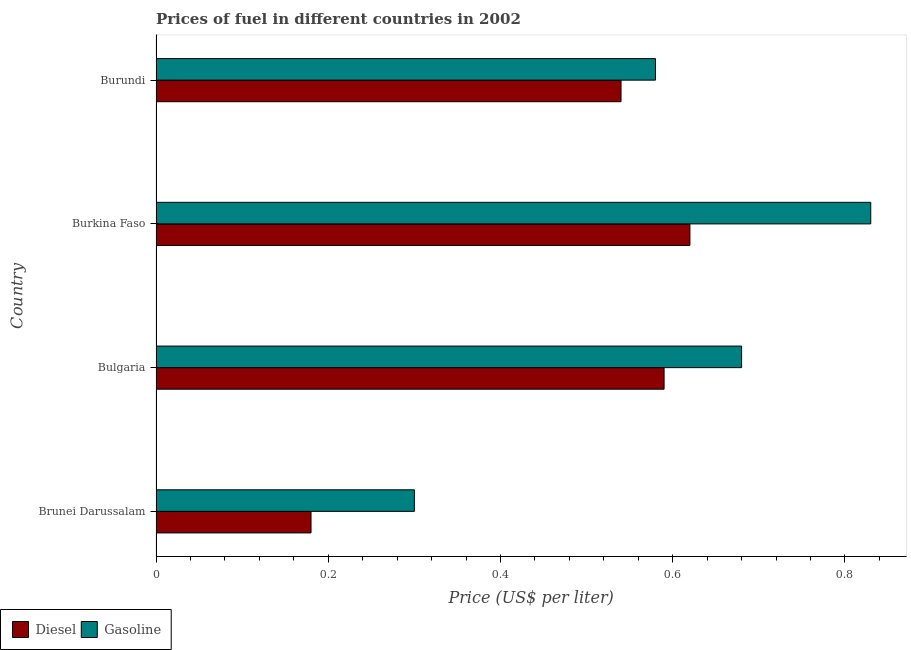Are the number of bars per tick equal to the number of legend labels?
Provide a short and direct response. Yes. What is the label of the 1st group of bars from the top?
Keep it short and to the point. Burundi. In how many cases, is the number of bars for a given country not equal to the number of legend labels?
Your answer should be compact. 0. What is the diesel price in Burundi?
Your response must be concise. 0.54. Across all countries, what is the maximum diesel price?
Give a very brief answer. 0.62. Across all countries, what is the minimum diesel price?
Provide a succinct answer. 0.18. In which country was the gasoline price maximum?
Provide a short and direct response. Burkina Faso. In which country was the gasoline price minimum?
Make the answer very short. Brunei Darussalam. What is the total gasoline price in the graph?
Provide a succinct answer. 2.39. What is the difference between the diesel price in Brunei Darussalam and that in Burundi?
Provide a succinct answer. -0.36. What is the difference between the gasoline price in Burundi and the diesel price in Brunei Darussalam?
Keep it short and to the point. 0.4. What is the average gasoline price per country?
Your answer should be compact. 0.6. What is the difference between the gasoline price and diesel price in Brunei Darussalam?
Make the answer very short. 0.12. In how many countries, is the gasoline price greater than 0.36 US$ per litre?
Provide a succinct answer. 3. What is the ratio of the gasoline price in Burkina Faso to that in Burundi?
Provide a succinct answer. 1.43. Is the difference between the gasoline price in Brunei Darussalam and Burkina Faso greater than the difference between the diesel price in Brunei Darussalam and Burkina Faso?
Provide a succinct answer. No. What is the difference between the highest and the lowest gasoline price?
Ensure brevity in your answer.  0.53. In how many countries, is the diesel price greater than the average diesel price taken over all countries?
Give a very brief answer. 3. Is the sum of the diesel price in Brunei Darussalam and Burundi greater than the maximum gasoline price across all countries?
Ensure brevity in your answer.  No. What does the 1st bar from the top in Bulgaria represents?
Provide a succinct answer. Gasoline. What does the 2nd bar from the bottom in Burundi represents?
Provide a short and direct response. Gasoline. How many countries are there in the graph?
Give a very brief answer. 4. Where does the legend appear in the graph?
Provide a succinct answer. Bottom left. How are the legend labels stacked?
Give a very brief answer. Horizontal. What is the title of the graph?
Provide a succinct answer. Prices of fuel in different countries in 2002. What is the label or title of the X-axis?
Your answer should be very brief. Price (US$ per liter). What is the Price (US$ per liter) in Diesel in Brunei Darussalam?
Ensure brevity in your answer.  0.18. What is the Price (US$ per liter) of Diesel in Bulgaria?
Provide a short and direct response. 0.59. What is the Price (US$ per liter) of Gasoline in Bulgaria?
Your answer should be compact. 0.68. What is the Price (US$ per liter) in Diesel in Burkina Faso?
Provide a succinct answer. 0.62. What is the Price (US$ per liter) in Gasoline in Burkina Faso?
Provide a short and direct response. 0.83. What is the Price (US$ per liter) in Diesel in Burundi?
Ensure brevity in your answer.  0.54. What is the Price (US$ per liter) in Gasoline in Burundi?
Your response must be concise. 0.58. Across all countries, what is the maximum Price (US$ per liter) of Diesel?
Keep it short and to the point. 0.62. Across all countries, what is the maximum Price (US$ per liter) in Gasoline?
Your answer should be compact. 0.83. Across all countries, what is the minimum Price (US$ per liter) in Diesel?
Your response must be concise. 0.18. Across all countries, what is the minimum Price (US$ per liter) of Gasoline?
Your response must be concise. 0.3. What is the total Price (US$ per liter) of Diesel in the graph?
Your answer should be compact. 1.93. What is the total Price (US$ per liter) in Gasoline in the graph?
Your response must be concise. 2.39. What is the difference between the Price (US$ per liter) in Diesel in Brunei Darussalam and that in Bulgaria?
Offer a terse response. -0.41. What is the difference between the Price (US$ per liter) of Gasoline in Brunei Darussalam and that in Bulgaria?
Keep it short and to the point. -0.38. What is the difference between the Price (US$ per liter) of Diesel in Brunei Darussalam and that in Burkina Faso?
Your answer should be very brief. -0.44. What is the difference between the Price (US$ per liter) in Gasoline in Brunei Darussalam and that in Burkina Faso?
Give a very brief answer. -0.53. What is the difference between the Price (US$ per liter) in Diesel in Brunei Darussalam and that in Burundi?
Your response must be concise. -0.36. What is the difference between the Price (US$ per liter) in Gasoline in Brunei Darussalam and that in Burundi?
Your response must be concise. -0.28. What is the difference between the Price (US$ per liter) of Diesel in Bulgaria and that in Burkina Faso?
Keep it short and to the point. -0.03. What is the difference between the Price (US$ per liter) of Diesel in Bulgaria and that in Burundi?
Your answer should be compact. 0.05. What is the difference between the Price (US$ per liter) in Gasoline in Burkina Faso and that in Burundi?
Offer a very short reply. 0.25. What is the difference between the Price (US$ per liter) of Diesel in Brunei Darussalam and the Price (US$ per liter) of Gasoline in Bulgaria?
Provide a succinct answer. -0.5. What is the difference between the Price (US$ per liter) in Diesel in Brunei Darussalam and the Price (US$ per liter) in Gasoline in Burkina Faso?
Ensure brevity in your answer.  -0.65. What is the difference between the Price (US$ per liter) in Diesel in Brunei Darussalam and the Price (US$ per liter) in Gasoline in Burundi?
Offer a terse response. -0.4. What is the difference between the Price (US$ per liter) in Diesel in Bulgaria and the Price (US$ per liter) in Gasoline in Burkina Faso?
Offer a very short reply. -0.24. What is the difference between the Price (US$ per liter) in Diesel in Bulgaria and the Price (US$ per liter) in Gasoline in Burundi?
Ensure brevity in your answer.  0.01. What is the average Price (US$ per liter) in Diesel per country?
Your response must be concise. 0.48. What is the average Price (US$ per liter) in Gasoline per country?
Your response must be concise. 0.6. What is the difference between the Price (US$ per liter) in Diesel and Price (US$ per liter) in Gasoline in Brunei Darussalam?
Offer a very short reply. -0.12. What is the difference between the Price (US$ per liter) of Diesel and Price (US$ per liter) of Gasoline in Bulgaria?
Offer a very short reply. -0.09. What is the difference between the Price (US$ per liter) in Diesel and Price (US$ per liter) in Gasoline in Burkina Faso?
Provide a short and direct response. -0.21. What is the difference between the Price (US$ per liter) in Diesel and Price (US$ per liter) in Gasoline in Burundi?
Offer a very short reply. -0.04. What is the ratio of the Price (US$ per liter) in Diesel in Brunei Darussalam to that in Bulgaria?
Offer a terse response. 0.31. What is the ratio of the Price (US$ per liter) of Gasoline in Brunei Darussalam to that in Bulgaria?
Keep it short and to the point. 0.44. What is the ratio of the Price (US$ per liter) of Diesel in Brunei Darussalam to that in Burkina Faso?
Offer a very short reply. 0.29. What is the ratio of the Price (US$ per liter) in Gasoline in Brunei Darussalam to that in Burkina Faso?
Give a very brief answer. 0.36. What is the ratio of the Price (US$ per liter) of Gasoline in Brunei Darussalam to that in Burundi?
Provide a short and direct response. 0.52. What is the ratio of the Price (US$ per liter) in Diesel in Bulgaria to that in Burkina Faso?
Your response must be concise. 0.95. What is the ratio of the Price (US$ per liter) of Gasoline in Bulgaria to that in Burkina Faso?
Your answer should be very brief. 0.82. What is the ratio of the Price (US$ per liter) of Diesel in Bulgaria to that in Burundi?
Your answer should be compact. 1.09. What is the ratio of the Price (US$ per liter) of Gasoline in Bulgaria to that in Burundi?
Your response must be concise. 1.17. What is the ratio of the Price (US$ per liter) in Diesel in Burkina Faso to that in Burundi?
Ensure brevity in your answer.  1.15. What is the ratio of the Price (US$ per liter) in Gasoline in Burkina Faso to that in Burundi?
Keep it short and to the point. 1.43. What is the difference between the highest and the lowest Price (US$ per liter) of Diesel?
Your answer should be compact. 0.44. What is the difference between the highest and the lowest Price (US$ per liter) of Gasoline?
Keep it short and to the point. 0.53. 